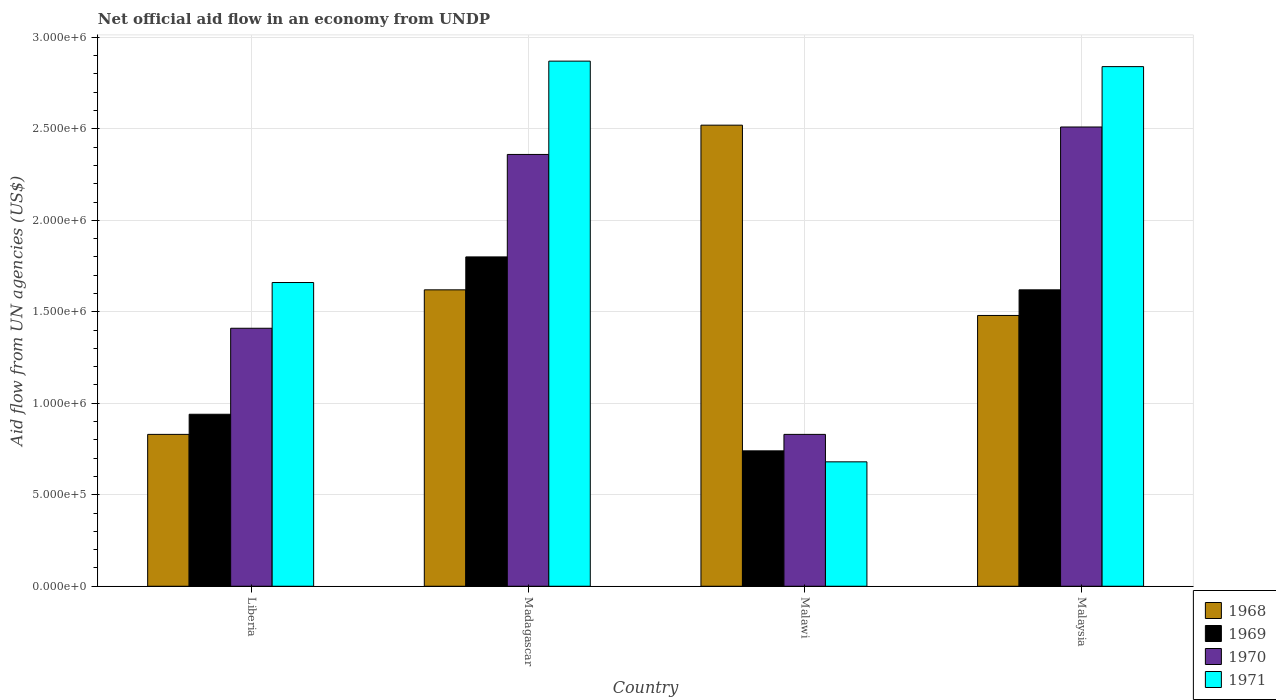How many different coloured bars are there?
Offer a very short reply. 4. How many groups of bars are there?
Provide a short and direct response. 4. Are the number of bars on each tick of the X-axis equal?
Keep it short and to the point. Yes. What is the label of the 4th group of bars from the left?
Offer a very short reply. Malaysia. What is the net official aid flow in 1968 in Madagascar?
Provide a short and direct response. 1.62e+06. Across all countries, what is the maximum net official aid flow in 1970?
Your response must be concise. 2.51e+06. Across all countries, what is the minimum net official aid flow in 1971?
Your response must be concise. 6.80e+05. In which country was the net official aid flow in 1969 maximum?
Give a very brief answer. Madagascar. In which country was the net official aid flow in 1968 minimum?
Offer a very short reply. Liberia. What is the total net official aid flow in 1969 in the graph?
Provide a succinct answer. 5.10e+06. What is the difference between the net official aid flow in 1969 in Malawi and that in Malaysia?
Make the answer very short. -8.80e+05. What is the difference between the net official aid flow in 1971 in Malaysia and the net official aid flow in 1969 in Liberia?
Keep it short and to the point. 1.90e+06. What is the average net official aid flow in 1968 per country?
Provide a succinct answer. 1.61e+06. What is the difference between the net official aid flow of/in 1971 and net official aid flow of/in 1969 in Malaysia?
Give a very brief answer. 1.22e+06. What is the ratio of the net official aid flow in 1970 in Liberia to that in Malawi?
Keep it short and to the point. 1.7. Is the difference between the net official aid flow in 1971 in Liberia and Malawi greater than the difference between the net official aid flow in 1969 in Liberia and Malawi?
Keep it short and to the point. Yes. What is the difference between the highest and the second highest net official aid flow in 1970?
Offer a terse response. 1.10e+06. What is the difference between the highest and the lowest net official aid flow in 1971?
Offer a terse response. 2.19e+06. In how many countries, is the net official aid flow in 1969 greater than the average net official aid flow in 1969 taken over all countries?
Keep it short and to the point. 2. What does the 2nd bar from the left in Malawi represents?
Your response must be concise. 1969. How many bars are there?
Keep it short and to the point. 16. Are all the bars in the graph horizontal?
Offer a terse response. No. How many countries are there in the graph?
Your response must be concise. 4. What is the difference between two consecutive major ticks on the Y-axis?
Offer a very short reply. 5.00e+05. Are the values on the major ticks of Y-axis written in scientific E-notation?
Your answer should be very brief. Yes. Does the graph contain any zero values?
Offer a terse response. No. Does the graph contain grids?
Your answer should be very brief. Yes. How are the legend labels stacked?
Your answer should be compact. Vertical. What is the title of the graph?
Offer a terse response. Net official aid flow in an economy from UNDP. Does "1999" appear as one of the legend labels in the graph?
Give a very brief answer. No. What is the label or title of the X-axis?
Provide a succinct answer. Country. What is the label or title of the Y-axis?
Your answer should be compact. Aid flow from UN agencies (US$). What is the Aid flow from UN agencies (US$) of 1968 in Liberia?
Your response must be concise. 8.30e+05. What is the Aid flow from UN agencies (US$) in 1969 in Liberia?
Keep it short and to the point. 9.40e+05. What is the Aid flow from UN agencies (US$) of 1970 in Liberia?
Provide a succinct answer. 1.41e+06. What is the Aid flow from UN agencies (US$) in 1971 in Liberia?
Provide a short and direct response. 1.66e+06. What is the Aid flow from UN agencies (US$) in 1968 in Madagascar?
Your response must be concise. 1.62e+06. What is the Aid flow from UN agencies (US$) of 1969 in Madagascar?
Provide a short and direct response. 1.80e+06. What is the Aid flow from UN agencies (US$) of 1970 in Madagascar?
Provide a short and direct response. 2.36e+06. What is the Aid flow from UN agencies (US$) in 1971 in Madagascar?
Make the answer very short. 2.87e+06. What is the Aid flow from UN agencies (US$) of 1968 in Malawi?
Provide a succinct answer. 2.52e+06. What is the Aid flow from UN agencies (US$) of 1969 in Malawi?
Ensure brevity in your answer.  7.40e+05. What is the Aid flow from UN agencies (US$) in 1970 in Malawi?
Keep it short and to the point. 8.30e+05. What is the Aid flow from UN agencies (US$) in 1971 in Malawi?
Offer a very short reply. 6.80e+05. What is the Aid flow from UN agencies (US$) in 1968 in Malaysia?
Keep it short and to the point. 1.48e+06. What is the Aid flow from UN agencies (US$) of 1969 in Malaysia?
Your response must be concise. 1.62e+06. What is the Aid flow from UN agencies (US$) of 1970 in Malaysia?
Your response must be concise. 2.51e+06. What is the Aid flow from UN agencies (US$) in 1971 in Malaysia?
Offer a terse response. 2.84e+06. Across all countries, what is the maximum Aid flow from UN agencies (US$) of 1968?
Your answer should be compact. 2.52e+06. Across all countries, what is the maximum Aid flow from UN agencies (US$) in 1969?
Give a very brief answer. 1.80e+06. Across all countries, what is the maximum Aid flow from UN agencies (US$) of 1970?
Offer a terse response. 2.51e+06. Across all countries, what is the maximum Aid flow from UN agencies (US$) in 1971?
Keep it short and to the point. 2.87e+06. Across all countries, what is the minimum Aid flow from UN agencies (US$) in 1968?
Your answer should be compact. 8.30e+05. Across all countries, what is the minimum Aid flow from UN agencies (US$) in 1969?
Make the answer very short. 7.40e+05. Across all countries, what is the minimum Aid flow from UN agencies (US$) of 1970?
Your answer should be compact. 8.30e+05. Across all countries, what is the minimum Aid flow from UN agencies (US$) in 1971?
Offer a very short reply. 6.80e+05. What is the total Aid flow from UN agencies (US$) of 1968 in the graph?
Provide a short and direct response. 6.45e+06. What is the total Aid flow from UN agencies (US$) of 1969 in the graph?
Provide a short and direct response. 5.10e+06. What is the total Aid flow from UN agencies (US$) in 1970 in the graph?
Give a very brief answer. 7.11e+06. What is the total Aid flow from UN agencies (US$) in 1971 in the graph?
Ensure brevity in your answer.  8.05e+06. What is the difference between the Aid flow from UN agencies (US$) in 1968 in Liberia and that in Madagascar?
Provide a short and direct response. -7.90e+05. What is the difference between the Aid flow from UN agencies (US$) of 1969 in Liberia and that in Madagascar?
Offer a terse response. -8.60e+05. What is the difference between the Aid flow from UN agencies (US$) of 1970 in Liberia and that in Madagascar?
Provide a short and direct response. -9.50e+05. What is the difference between the Aid flow from UN agencies (US$) of 1971 in Liberia and that in Madagascar?
Your answer should be very brief. -1.21e+06. What is the difference between the Aid flow from UN agencies (US$) of 1968 in Liberia and that in Malawi?
Provide a succinct answer. -1.69e+06. What is the difference between the Aid flow from UN agencies (US$) of 1970 in Liberia and that in Malawi?
Give a very brief answer. 5.80e+05. What is the difference between the Aid flow from UN agencies (US$) of 1971 in Liberia and that in Malawi?
Your answer should be compact. 9.80e+05. What is the difference between the Aid flow from UN agencies (US$) of 1968 in Liberia and that in Malaysia?
Keep it short and to the point. -6.50e+05. What is the difference between the Aid flow from UN agencies (US$) in 1969 in Liberia and that in Malaysia?
Provide a short and direct response. -6.80e+05. What is the difference between the Aid flow from UN agencies (US$) in 1970 in Liberia and that in Malaysia?
Your answer should be compact. -1.10e+06. What is the difference between the Aid flow from UN agencies (US$) in 1971 in Liberia and that in Malaysia?
Offer a very short reply. -1.18e+06. What is the difference between the Aid flow from UN agencies (US$) in 1968 in Madagascar and that in Malawi?
Provide a short and direct response. -9.00e+05. What is the difference between the Aid flow from UN agencies (US$) of 1969 in Madagascar and that in Malawi?
Your answer should be compact. 1.06e+06. What is the difference between the Aid flow from UN agencies (US$) in 1970 in Madagascar and that in Malawi?
Give a very brief answer. 1.53e+06. What is the difference between the Aid flow from UN agencies (US$) of 1971 in Madagascar and that in Malawi?
Make the answer very short. 2.19e+06. What is the difference between the Aid flow from UN agencies (US$) in 1968 in Malawi and that in Malaysia?
Provide a short and direct response. 1.04e+06. What is the difference between the Aid flow from UN agencies (US$) in 1969 in Malawi and that in Malaysia?
Your answer should be compact. -8.80e+05. What is the difference between the Aid flow from UN agencies (US$) of 1970 in Malawi and that in Malaysia?
Give a very brief answer. -1.68e+06. What is the difference between the Aid flow from UN agencies (US$) in 1971 in Malawi and that in Malaysia?
Provide a short and direct response. -2.16e+06. What is the difference between the Aid flow from UN agencies (US$) of 1968 in Liberia and the Aid flow from UN agencies (US$) of 1969 in Madagascar?
Provide a short and direct response. -9.70e+05. What is the difference between the Aid flow from UN agencies (US$) of 1968 in Liberia and the Aid flow from UN agencies (US$) of 1970 in Madagascar?
Your answer should be very brief. -1.53e+06. What is the difference between the Aid flow from UN agencies (US$) in 1968 in Liberia and the Aid flow from UN agencies (US$) in 1971 in Madagascar?
Offer a very short reply. -2.04e+06. What is the difference between the Aid flow from UN agencies (US$) in 1969 in Liberia and the Aid flow from UN agencies (US$) in 1970 in Madagascar?
Make the answer very short. -1.42e+06. What is the difference between the Aid flow from UN agencies (US$) in 1969 in Liberia and the Aid flow from UN agencies (US$) in 1971 in Madagascar?
Your answer should be very brief. -1.93e+06. What is the difference between the Aid flow from UN agencies (US$) of 1970 in Liberia and the Aid flow from UN agencies (US$) of 1971 in Madagascar?
Offer a very short reply. -1.46e+06. What is the difference between the Aid flow from UN agencies (US$) in 1968 in Liberia and the Aid flow from UN agencies (US$) in 1969 in Malawi?
Give a very brief answer. 9.00e+04. What is the difference between the Aid flow from UN agencies (US$) of 1968 in Liberia and the Aid flow from UN agencies (US$) of 1970 in Malawi?
Ensure brevity in your answer.  0. What is the difference between the Aid flow from UN agencies (US$) in 1968 in Liberia and the Aid flow from UN agencies (US$) in 1971 in Malawi?
Your answer should be very brief. 1.50e+05. What is the difference between the Aid flow from UN agencies (US$) in 1970 in Liberia and the Aid flow from UN agencies (US$) in 1971 in Malawi?
Your answer should be compact. 7.30e+05. What is the difference between the Aid flow from UN agencies (US$) of 1968 in Liberia and the Aid flow from UN agencies (US$) of 1969 in Malaysia?
Provide a short and direct response. -7.90e+05. What is the difference between the Aid flow from UN agencies (US$) in 1968 in Liberia and the Aid flow from UN agencies (US$) in 1970 in Malaysia?
Give a very brief answer. -1.68e+06. What is the difference between the Aid flow from UN agencies (US$) of 1968 in Liberia and the Aid flow from UN agencies (US$) of 1971 in Malaysia?
Ensure brevity in your answer.  -2.01e+06. What is the difference between the Aid flow from UN agencies (US$) in 1969 in Liberia and the Aid flow from UN agencies (US$) in 1970 in Malaysia?
Make the answer very short. -1.57e+06. What is the difference between the Aid flow from UN agencies (US$) in 1969 in Liberia and the Aid flow from UN agencies (US$) in 1971 in Malaysia?
Your answer should be compact. -1.90e+06. What is the difference between the Aid flow from UN agencies (US$) in 1970 in Liberia and the Aid flow from UN agencies (US$) in 1971 in Malaysia?
Provide a short and direct response. -1.43e+06. What is the difference between the Aid flow from UN agencies (US$) in 1968 in Madagascar and the Aid flow from UN agencies (US$) in 1969 in Malawi?
Give a very brief answer. 8.80e+05. What is the difference between the Aid flow from UN agencies (US$) in 1968 in Madagascar and the Aid flow from UN agencies (US$) in 1970 in Malawi?
Provide a short and direct response. 7.90e+05. What is the difference between the Aid flow from UN agencies (US$) in 1968 in Madagascar and the Aid flow from UN agencies (US$) in 1971 in Malawi?
Make the answer very short. 9.40e+05. What is the difference between the Aid flow from UN agencies (US$) in 1969 in Madagascar and the Aid flow from UN agencies (US$) in 1970 in Malawi?
Your answer should be very brief. 9.70e+05. What is the difference between the Aid flow from UN agencies (US$) of 1969 in Madagascar and the Aid flow from UN agencies (US$) of 1971 in Malawi?
Make the answer very short. 1.12e+06. What is the difference between the Aid flow from UN agencies (US$) in 1970 in Madagascar and the Aid flow from UN agencies (US$) in 1971 in Malawi?
Keep it short and to the point. 1.68e+06. What is the difference between the Aid flow from UN agencies (US$) in 1968 in Madagascar and the Aid flow from UN agencies (US$) in 1969 in Malaysia?
Make the answer very short. 0. What is the difference between the Aid flow from UN agencies (US$) of 1968 in Madagascar and the Aid flow from UN agencies (US$) of 1970 in Malaysia?
Your response must be concise. -8.90e+05. What is the difference between the Aid flow from UN agencies (US$) of 1968 in Madagascar and the Aid flow from UN agencies (US$) of 1971 in Malaysia?
Provide a succinct answer. -1.22e+06. What is the difference between the Aid flow from UN agencies (US$) of 1969 in Madagascar and the Aid flow from UN agencies (US$) of 1970 in Malaysia?
Keep it short and to the point. -7.10e+05. What is the difference between the Aid flow from UN agencies (US$) of 1969 in Madagascar and the Aid flow from UN agencies (US$) of 1971 in Malaysia?
Ensure brevity in your answer.  -1.04e+06. What is the difference between the Aid flow from UN agencies (US$) in 1970 in Madagascar and the Aid flow from UN agencies (US$) in 1971 in Malaysia?
Your answer should be very brief. -4.80e+05. What is the difference between the Aid flow from UN agencies (US$) of 1968 in Malawi and the Aid flow from UN agencies (US$) of 1970 in Malaysia?
Offer a terse response. 10000. What is the difference between the Aid flow from UN agencies (US$) of 1968 in Malawi and the Aid flow from UN agencies (US$) of 1971 in Malaysia?
Give a very brief answer. -3.20e+05. What is the difference between the Aid flow from UN agencies (US$) of 1969 in Malawi and the Aid flow from UN agencies (US$) of 1970 in Malaysia?
Ensure brevity in your answer.  -1.77e+06. What is the difference between the Aid flow from UN agencies (US$) of 1969 in Malawi and the Aid flow from UN agencies (US$) of 1971 in Malaysia?
Your response must be concise. -2.10e+06. What is the difference between the Aid flow from UN agencies (US$) of 1970 in Malawi and the Aid flow from UN agencies (US$) of 1971 in Malaysia?
Ensure brevity in your answer.  -2.01e+06. What is the average Aid flow from UN agencies (US$) of 1968 per country?
Provide a short and direct response. 1.61e+06. What is the average Aid flow from UN agencies (US$) in 1969 per country?
Ensure brevity in your answer.  1.28e+06. What is the average Aid flow from UN agencies (US$) of 1970 per country?
Offer a terse response. 1.78e+06. What is the average Aid flow from UN agencies (US$) in 1971 per country?
Provide a succinct answer. 2.01e+06. What is the difference between the Aid flow from UN agencies (US$) of 1968 and Aid flow from UN agencies (US$) of 1970 in Liberia?
Provide a succinct answer. -5.80e+05. What is the difference between the Aid flow from UN agencies (US$) in 1968 and Aid flow from UN agencies (US$) in 1971 in Liberia?
Your answer should be compact. -8.30e+05. What is the difference between the Aid flow from UN agencies (US$) of 1969 and Aid flow from UN agencies (US$) of 1970 in Liberia?
Provide a succinct answer. -4.70e+05. What is the difference between the Aid flow from UN agencies (US$) of 1969 and Aid flow from UN agencies (US$) of 1971 in Liberia?
Give a very brief answer. -7.20e+05. What is the difference between the Aid flow from UN agencies (US$) of 1968 and Aid flow from UN agencies (US$) of 1969 in Madagascar?
Provide a succinct answer. -1.80e+05. What is the difference between the Aid flow from UN agencies (US$) of 1968 and Aid flow from UN agencies (US$) of 1970 in Madagascar?
Provide a succinct answer. -7.40e+05. What is the difference between the Aid flow from UN agencies (US$) in 1968 and Aid flow from UN agencies (US$) in 1971 in Madagascar?
Provide a short and direct response. -1.25e+06. What is the difference between the Aid flow from UN agencies (US$) of 1969 and Aid flow from UN agencies (US$) of 1970 in Madagascar?
Your answer should be very brief. -5.60e+05. What is the difference between the Aid flow from UN agencies (US$) of 1969 and Aid flow from UN agencies (US$) of 1971 in Madagascar?
Your answer should be compact. -1.07e+06. What is the difference between the Aid flow from UN agencies (US$) in 1970 and Aid flow from UN agencies (US$) in 1971 in Madagascar?
Offer a very short reply. -5.10e+05. What is the difference between the Aid flow from UN agencies (US$) of 1968 and Aid flow from UN agencies (US$) of 1969 in Malawi?
Your response must be concise. 1.78e+06. What is the difference between the Aid flow from UN agencies (US$) in 1968 and Aid flow from UN agencies (US$) in 1970 in Malawi?
Give a very brief answer. 1.69e+06. What is the difference between the Aid flow from UN agencies (US$) of 1968 and Aid flow from UN agencies (US$) of 1971 in Malawi?
Provide a succinct answer. 1.84e+06. What is the difference between the Aid flow from UN agencies (US$) of 1968 and Aid flow from UN agencies (US$) of 1969 in Malaysia?
Give a very brief answer. -1.40e+05. What is the difference between the Aid flow from UN agencies (US$) of 1968 and Aid flow from UN agencies (US$) of 1970 in Malaysia?
Keep it short and to the point. -1.03e+06. What is the difference between the Aid flow from UN agencies (US$) of 1968 and Aid flow from UN agencies (US$) of 1971 in Malaysia?
Your response must be concise. -1.36e+06. What is the difference between the Aid flow from UN agencies (US$) of 1969 and Aid flow from UN agencies (US$) of 1970 in Malaysia?
Your answer should be compact. -8.90e+05. What is the difference between the Aid flow from UN agencies (US$) of 1969 and Aid flow from UN agencies (US$) of 1971 in Malaysia?
Your answer should be very brief. -1.22e+06. What is the difference between the Aid flow from UN agencies (US$) in 1970 and Aid flow from UN agencies (US$) in 1971 in Malaysia?
Provide a succinct answer. -3.30e+05. What is the ratio of the Aid flow from UN agencies (US$) in 1968 in Liberia to that in Madagascar?
Provide a short and direct response. 0.51. What is the ratio of the Aid flow from UN agencies (US$) in 1969 in Liberia to that in Madagascar?
Offer a very short reply. 0.52. What is the ratio of the Aid flow from UN agencies (US$) in 1970 in Liberia to that in Madagascar?
Keep it short and to the point. 0.6. What is the ratio of the Aid flow from UN agencies (US$) in 1971 in Liberia to that in Madagascar?
Keep it short and to the point. 0.58. What is the ratio of the Aid flow from UN agencies (US$) in 1968 in Liberia to that in Malawi?
Give a very brief answer. 0.33. What is the ratio of the Aid flow from UN agencies (US$) of 1969 in Liberia to that in Malawi?
Keep it short and to the point. 1.27. What is the ratio of the Aid flow from UN agencies (US$) in 1970 in Liberia to that in Malawi?
Offer a terse response. 1.7. What is the ratio of the Aid flow from UN agencies (US$) of 1971 in Liberia to that in Malawi?
Offer a terse response. 2.44. What is the ratio of the Aid flow from UN agencies (US$) in 1968 in Liberia to that in Malaysia?
Your response must be concise. 0.56. What is the ratio of the Aid flow from UN agencies (US$) of 1969 in Liberia to that in Malaysia?
Offer a terse response. 0.58. What is the ratio of the Aid flow from UN agencies (US$) in 1970 in Liberia to that in Malaysia?
Provide a short and direct response. 0.56. What is the ratio of the Aid flow from UN agencies (US$) of 1971 in Liberia to that in Malaysia?
Your answer should be compact. 0.58. What is the ratio of the Aid flow from UN agencies (US$) in 1968 in Madagascar to that in Malawi?
Give a very brief answer. 0.64. What is the ratio of the Aid flow from UN agencies (US$) in 1969 in Madagascar to that in Malawi?
Provide a short and direct response. 2.43. What is the ratio of the Aid flow from UN agencies (US$) of 1970 in Madagascar to that in Malawi?
Keep it short and to the point. 2.84. What is the ratio of the Aid flow from UN agencies (US$) in 1971 in Madagascar to that in Malawi?
Your response must be concise. 4.22. What is the ratio of the Aid flow from UN agencies (US$) in 1968 in Madagascar to that in Malaysia?
Offer a terse response. 1.09. What is the ratio of the Aid flow from UN agencies (US$) in 1970 in Madagascar to that in Malaysia?
Make the answer very short. 0.94. What is the ratio of the Aid flow from UN agencies (US$) in 1971 in Madagascar to that in Malaysia?
Your answer should be compact. 1.01. What is the ratio of the Aid flow from UN agencies (US$) of 1968 in Malawi to that in Malaysia?
Your answer should be compact. 1.7. What is the ratio of the Aid flow from UN agencies (US$) in 1969 in Malawi to that in Malaysia?
Your answer should be very brief. 0.46. What is the ratio of the Aid flow from UN agencies (US$) in 1970 in Malawi to that in Malaysia?
Make the answer very short. 0.33. What is the ratio of the Aid flow from UN agencies (US$) of 1971 in Malawi to that in Malaysia?
Offer a terse response. 0.24. What is the difference between the highest and the second highest Aid flow from UN agencies (US$) in 1968?
Provide a short and direct response. 9.00e+05. What is the difference between the highest and the second highest Aid flow from UN agencies (US$) of 1970?
Your answer should be very brief. 1.50e+05. What is the difference between the highest and the second highest Aid flow from UN agencies (US$) of 1971?
Provide a short and direct response. 3.00e+04. What is the difference between the highest and the lowest Aid flow from UN agencies (US$) of 1968?
Make the answer very short. 1.69e+06. What is the difference between the highest and the lowest Aid flow from UN agencies (US$) of 1969?
Make the answer very short. 1.06e+06. What is the difference between the highest and the lowest Aid flow from UN agencies (US$) of 1970?
Your response must be concise. 1.68e+06. What is the difference between the highest and the lowest Aid flow from UN agencies (US$) of 1971?
Provide a succinct answer. 2.19e+06. 